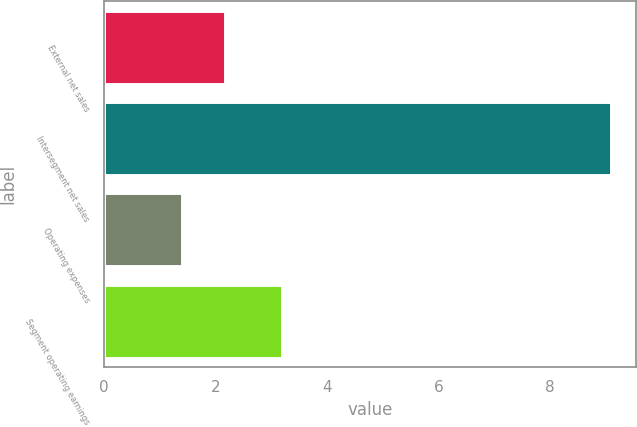Convert chart to OTSL. <chart><loc_0><loc_0><loc_500><loc_500><bar_chart><fcel>External net sales<fcel>Intersegment net sales<fcel>Operating expenses<fcel>Segment operating earnings<nl><fcel>2.17<fcel>9.1<fcel>1.4<fcel>3.2<nl></chart> 